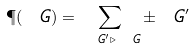Convert formula to latex. <formula><loc_0><loc_0><loc_500><loc_500>\P ( \ G ) = \sum _ { \ G ^ { \prime } \triangleright \ G } \pm \ G ^ { \prime }</formula> 